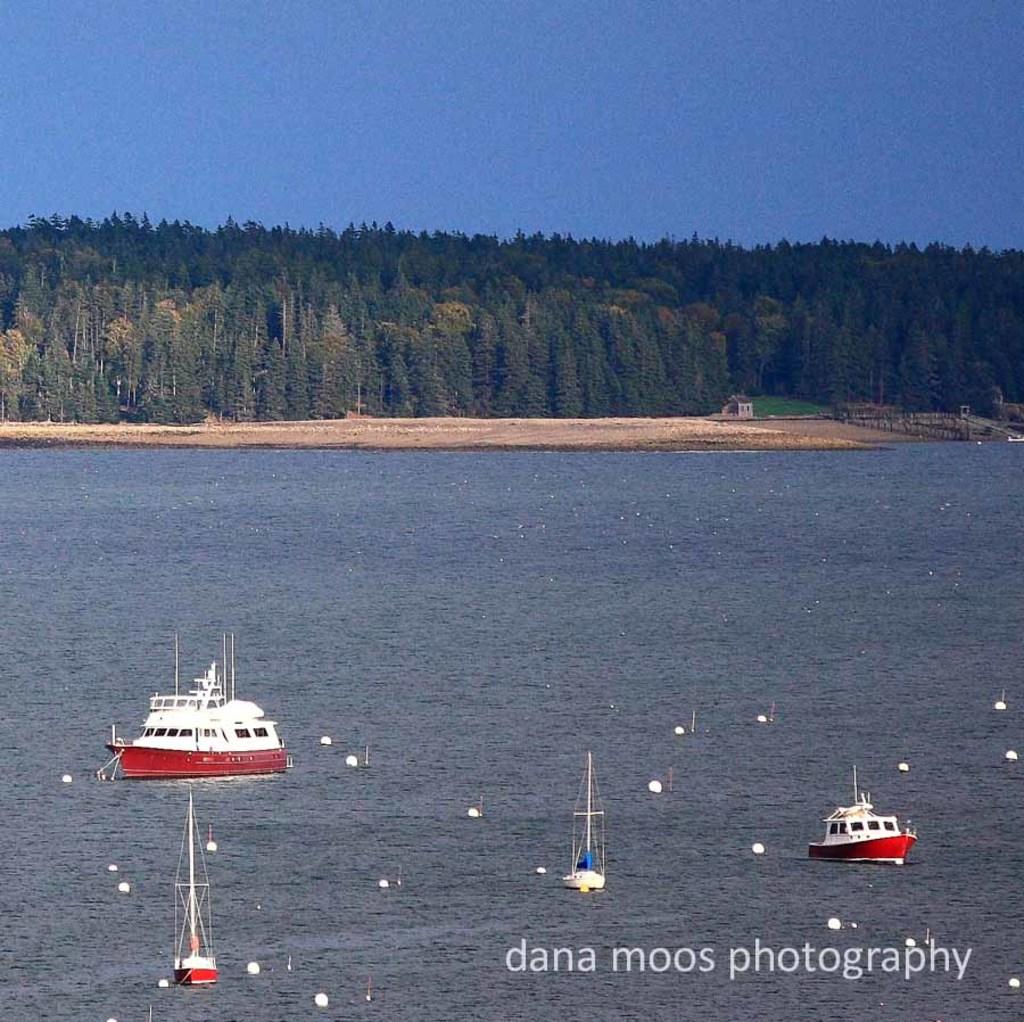Who took these photographs?
Your answer should be compact. Dana moos. 